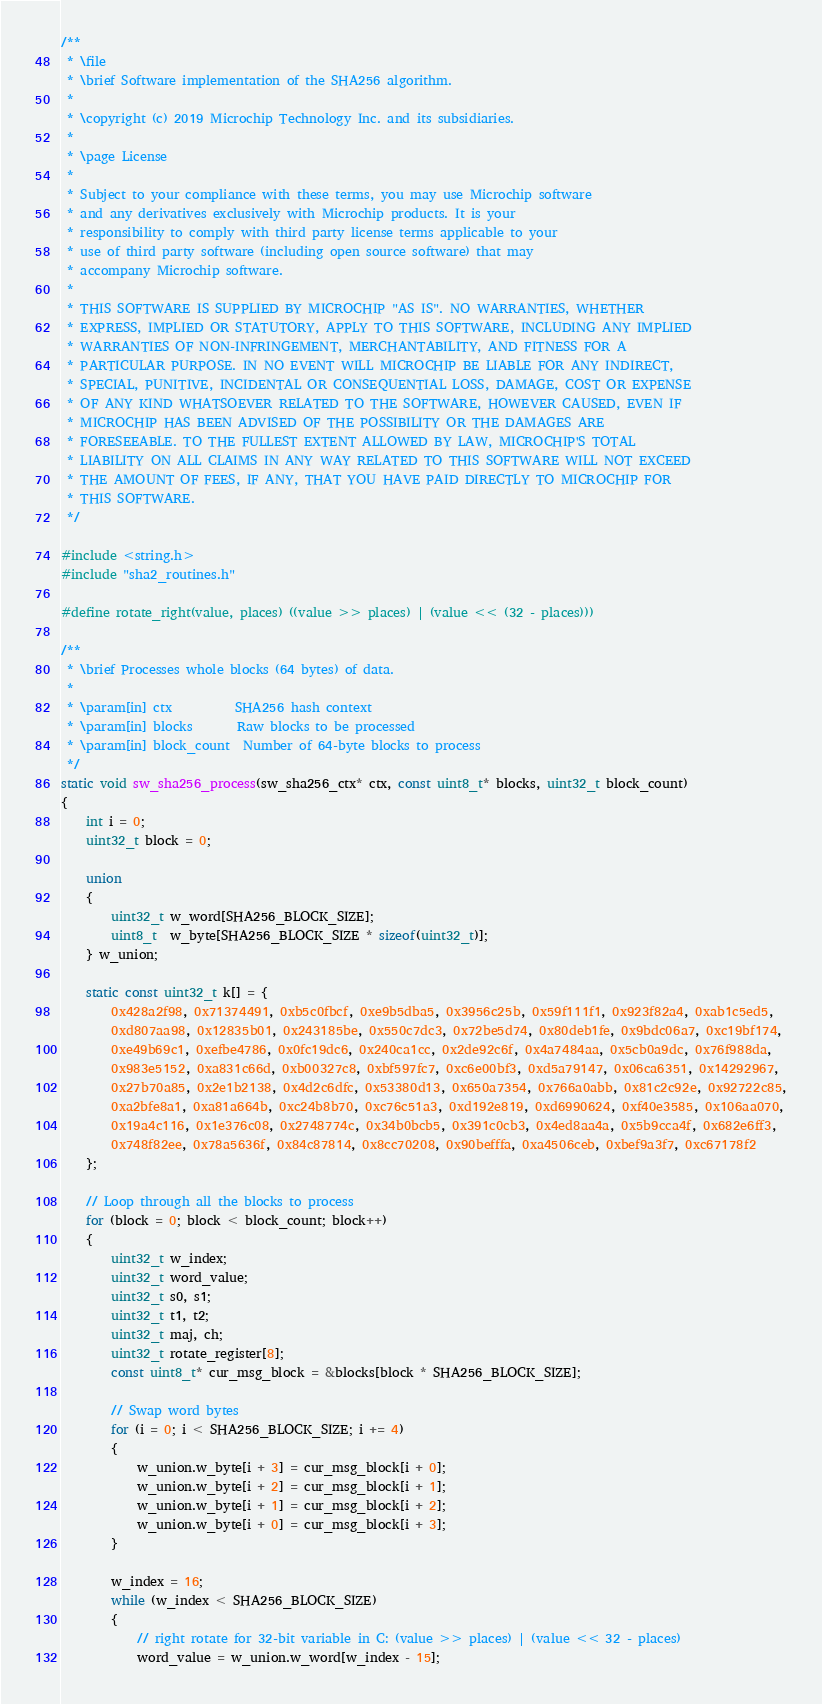<code> <loc_0><loc_0><loc_500><loc_500><_C_>/**
 * \file
 * \brief Software implementation of the SHA256 algorithm.
 *
 * \copyright (c) 2019 Microchip Technology Inc. and its subsidiaries.
 *
 * \page License
 *
 * Subject to your compliance with these terms, you may use Microchip software
 * and any derivatives exclusively with Microchip products. It is your
 * responsibility to comply with third party license terms applicable to your
 * use of third party software (including open source software) that may
 * accompany Microchip software.
 *
 * THIS SOFTWARE IS SUPPLIED BY MICROCHIP "AS IS". NO WARRANTIES, WHETHER
 * EXPRESS, IMPLIED OR STATUTORY, APPLY TO THIS SOFTWARE, INCLUDING ANY IMPLIED
 * WARRANTIES OF NON-INFRINGEMENT, MERCHANTABILITY, AND FITNESS FOR A
 * PARTICULAR PURPOSE. IN NO EVENT WILL MICROCHIP BE LIABLE FOR ANY INDIRECT,
 * SPECIAL, PUNITIVE, INCIDENTAL OR CONSEQUENTIAL LOSS, DAMAGE, COST OR EXPENSE
 * OF ANY KIND WHATSOEVER RELATED TO THE SOFTWARE, HOWEVER CAUSED, EVEN IF
 * MICROCHIP HAS BEEN ADVISED OF THE POSSIBILITY OR THE DAMAGES ARE
 * FORESEEABLE. TO THE FULLEST EXTENT ALLOWED BY LAW, MICROCHIP'S TOTAL
 * LIABILITY ON ALL CLAIMS IN ANY WAY RELATED TO THIS SOFTWARE WILL NOT EXCEED
 * THE AMOUNT OF FEES, IF ANY, THAT YOU HAVE PAID DIRECTLY TO MICROCHIP FOR
 * THIS SOFTWARE.
 */

#include <string.h>
#include "sha2_routines.h"

#define rotate_right(value, places) ((value >> places) | (value << (32 - places)))

/**
 * \brief Processes whole blocks (64 bytes) of data.
 *
 * \param[in] ctx          SHA256 hash context
 * \param[in] blocks       Raw blocks to be processed
 * \param[in] block_count  Number of 64-byte blocks to process
 */
static void sw_sha256_process(sw_sha256_ctx* ctx, const uint8_t* blocks, uint32_t block_count)
{
    int i = 0;
    uint32_t block = 0;

    union
    {
        uint32_t w_word[SHA256_BLOCK_SIZE];
        uint8_t  w_byte[SHA256_BLOCK_SIZE * sizeof(uint32_t)];
    } w_union;

    static const uint32_t k[] = {
        0x428a2f98, 0x71374491, 0xb5c0fbcf, 0xe9b5dba5, 0x3956c25b, 0x59f111f1, 0x923f82a4, 0xab1c5ed5,
        0xd807aa98, 0x12835b01, 0x243185be, 0x550c7dc3, 0x72be5d74, 0x80deb1fe, 0x9bdc06a7, 0xc19bf174,
        0xe49b69c1, 0xefbe4786, 0x0fc19dc6, 0x240ca1cc, 0x2de92c6f, 0x4a7484aa, 0x5cb0a9dc, 0x76f988da,
        0x983e5152, 0xa831c66d, 0xb00327c8, 0xbf597fc7, 0xc6e00bf3, 0xd5a79147, 0x06ca6351, 0x14292967,
        0x27b70a85, 0x2e1b2138, 0x4d2c6dfc, 0x53380d13, 0x650a7354, 0x766a0abb, 0x81c2c92e, 0x92722c85,
        0xa2bfe8a1, 0xa81a664b, 0xc24b8b70, 0xc76c51a3, 0xd192e819, 0xd6990624, 0xf40e3585, 0x106aa070,
        0x19a4c116, 0x1e376c08, 0x2748774c, 0x34b0bcb5, 0x391c0cb3, 0x4ed8aa4a, 0x5b9cca4f, 0x682e6ff3,
        0x748f82ee, 0x78a5636f, 0x84c87814, 0x8cc70208, 0x90befffa, 0xa4506ceb, 0xbef9a3f7, 0xc67178f2
    };

    // Loop through all the blocks to process
    for (block = 0; block < block_count; block++)
    {
        uint32_t w_index;
        uint32_t word_value;
        uint32_t s0, s1;
        uint32_t t1, t2;
        uint32_t maj, ch;
        uint32_t rotate_register[8];
        const uint8_t* cur_msg_block = &blocks[block * SHA256_BLOCK_SIZE];

        // Swap word bytes
        for (i = 0; i < SHA256_BLOCK_SIZE; i += 4)
        {
            w_union.w_byte[i + 3] = cur_msg_block[i + 0];
            w_union.w_byte[i + 2] = cur_msg_block[i + 1];
            w_union.w_byte[i + 1] = cur_msg_block[i + 2];
            w_union.w_byte[i + 0] = cur_msg_block[i + 3];
        }

        w_index = 16;
        while (w_index < SHA256_BLOCK_SIZE)
        {
            // right rotate for 32-bit variable in C: (value >> places) | (value << 32 - places)
            word_value = w_union.w_word[w_index - 15];</code> 